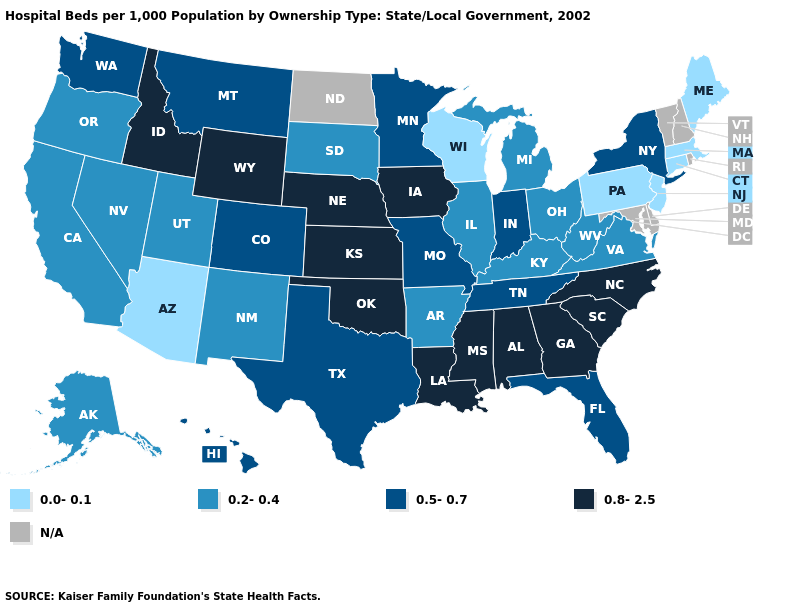What is the highest value in the South ?
Give a very brief answer. 0.8-2.5. Does the map have missing data?
Answer briefly. Yes. Does Connecticut have the lowest value in the Northeast?
Keep it brief. Yes. Which states have the highest value in the USA?
Keep it brief. Alabama, Georgia, Idaho, Iowa, Kansas, Louisiana, Mississippi, Nebraska, North Carolina, Oklahoma, South Carolina, Wyoming. What is the lowest value in states that border New Hampshire?
Keep it brief. 0.0-0.1. What is the value of Michigan?
Answer briefly. 0.2-0.4. What is the value of South Dakota?
Answer briefly. 0.2-0.4. Among the states that border Tennessee , does Alabama have the lowest value?
Give a very brief answer. No. Among the states that border Montana , does South Dakota have the lowest value?
Give a very brief answer. Yes. What is the highest value in states that border New York?
Concise answer only. 0.0-0.1. Which states have the lowest value in the USA?
Concise answer only. Arizona, Connecticut, Maine, Massachusetts, New Jersey, Pennsylvania, Wisconsin. Which states have the lowest value in the USA?
Answer briefly. Arizona, Connecticut, Maine, Massachusetts, New Jersey, Pennsylvania, Wisconsin. What is the value of New Hampshire?
Quick response, please. N/A. Does Wisconsin have the lowest value in the MidWest?
Write a very short answer. Yes. Name the states that have a value in the range 0.2-0.4?
Keep it brief. Alaska, Arkansas, California, Illinois, Kentucky, Michigan, Nevada, New Mexico, Ohio, Oregon, South Dakota, Utah, Virginia, West Virginia. 